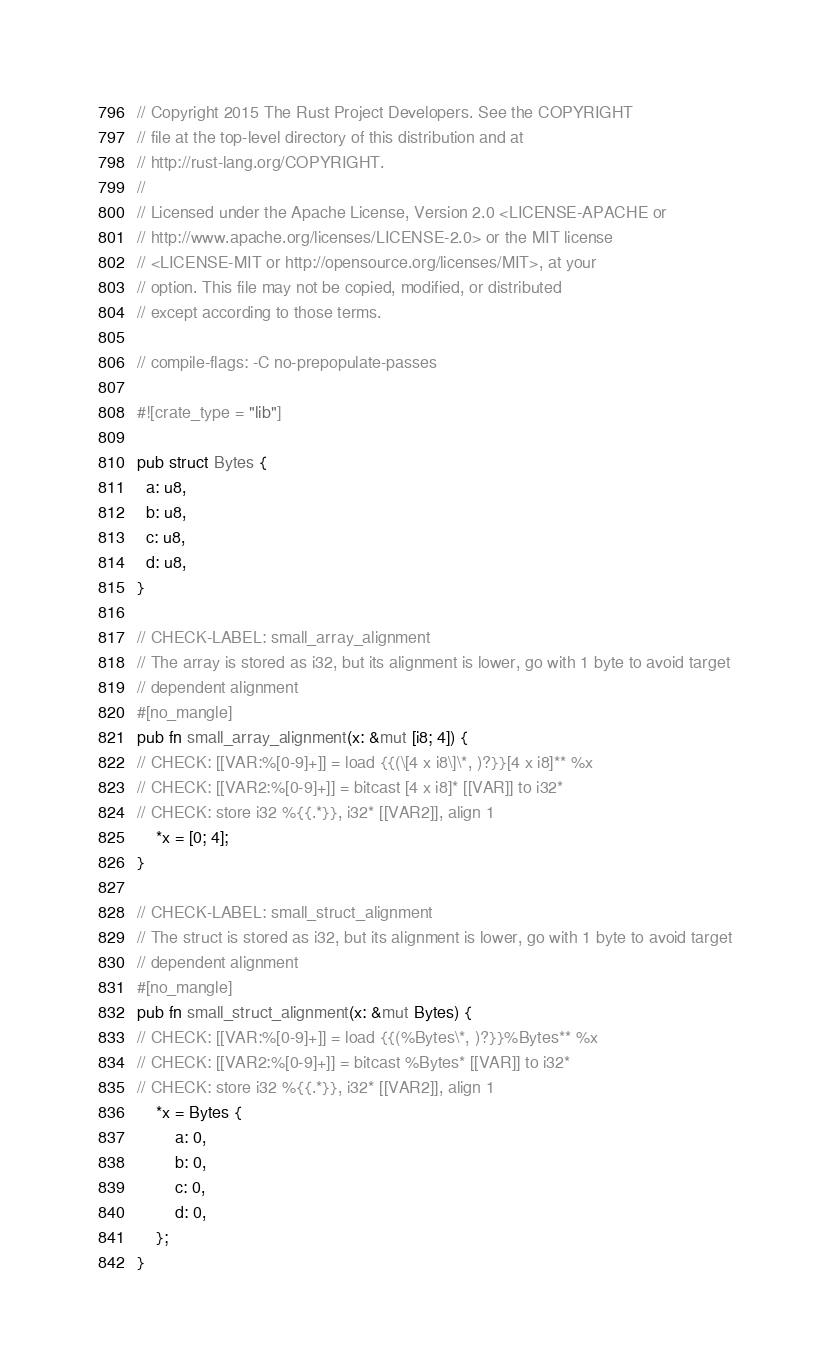<code> <loc_0><loc_0><loc_500><loc_500><_Rust_>// Copyright 2015 The Rust Project Developers. See the COPYRIGHT
// file at the top-level directory of this distribution and at
// http://rust-lang.org/COPYRIGHT.
//
// Licensed under the Apache License, Version 2.0 <LICENSE-APACHE or
// http://www.apache.org/licenses/LICENSE-2.0> or the MIT license
// <LICENSE-MIT or http://opensource.org/licenses/MIT>, at your
// option. This file may not be copied, modified, or distributed
// except according to those terms.

// compile-flags: -C no-prepopulate-passes

#![crate_type = "lib"]

pub struct Bytes {
  a: u8,
  b: u8,
  c: u8,
  d: u8,
}

// CHECK-LABEL: small_array_alignment
// The array is stored as i32, but its alignment is lower, go with 1 byte to avoid target
// dependent alignment
#[no_mangle]
pub fn small_array_alignment(x: &mut [i8; 4]) {
// CHECK: [[VAR:%[0-9]+]] = load {{(\[4 x i8\]\*, )?}}[4 x i8]** %x
// CHECK: [[VAR2:%[0-9]+]] = bitcast [4 x i8]* [[VAR]] to i32*
// CHECK: store i32 %{{.*}}, i32* [[VAR2]], align 1
    *x = [0; 4];
}

// CHECK-LABEL: small_struct_alignment
// The struct is stored as i32, but its alignment is lower, go with 1 byte to avoid target
// dependent alignment
#[no_mangle]
pub fn small_struct_alignment(x: &mut Bytes) {
// CHECK: [[VAR:%[0-9]+]] = load {{(%Bytes\*, )?}}%Bytes** %x
// CHECK: [[VAR2:%[0-9]+]] = bitcast %Bytes* [[VAR]] to i32*
// CHECK: store i32 %{{.*}}, i32* [[VAR2]], align 1
    *x = Bytes {
        a: 0,
        b: 0,
        c: 0,
        d: 0,
    };
}
</code> 